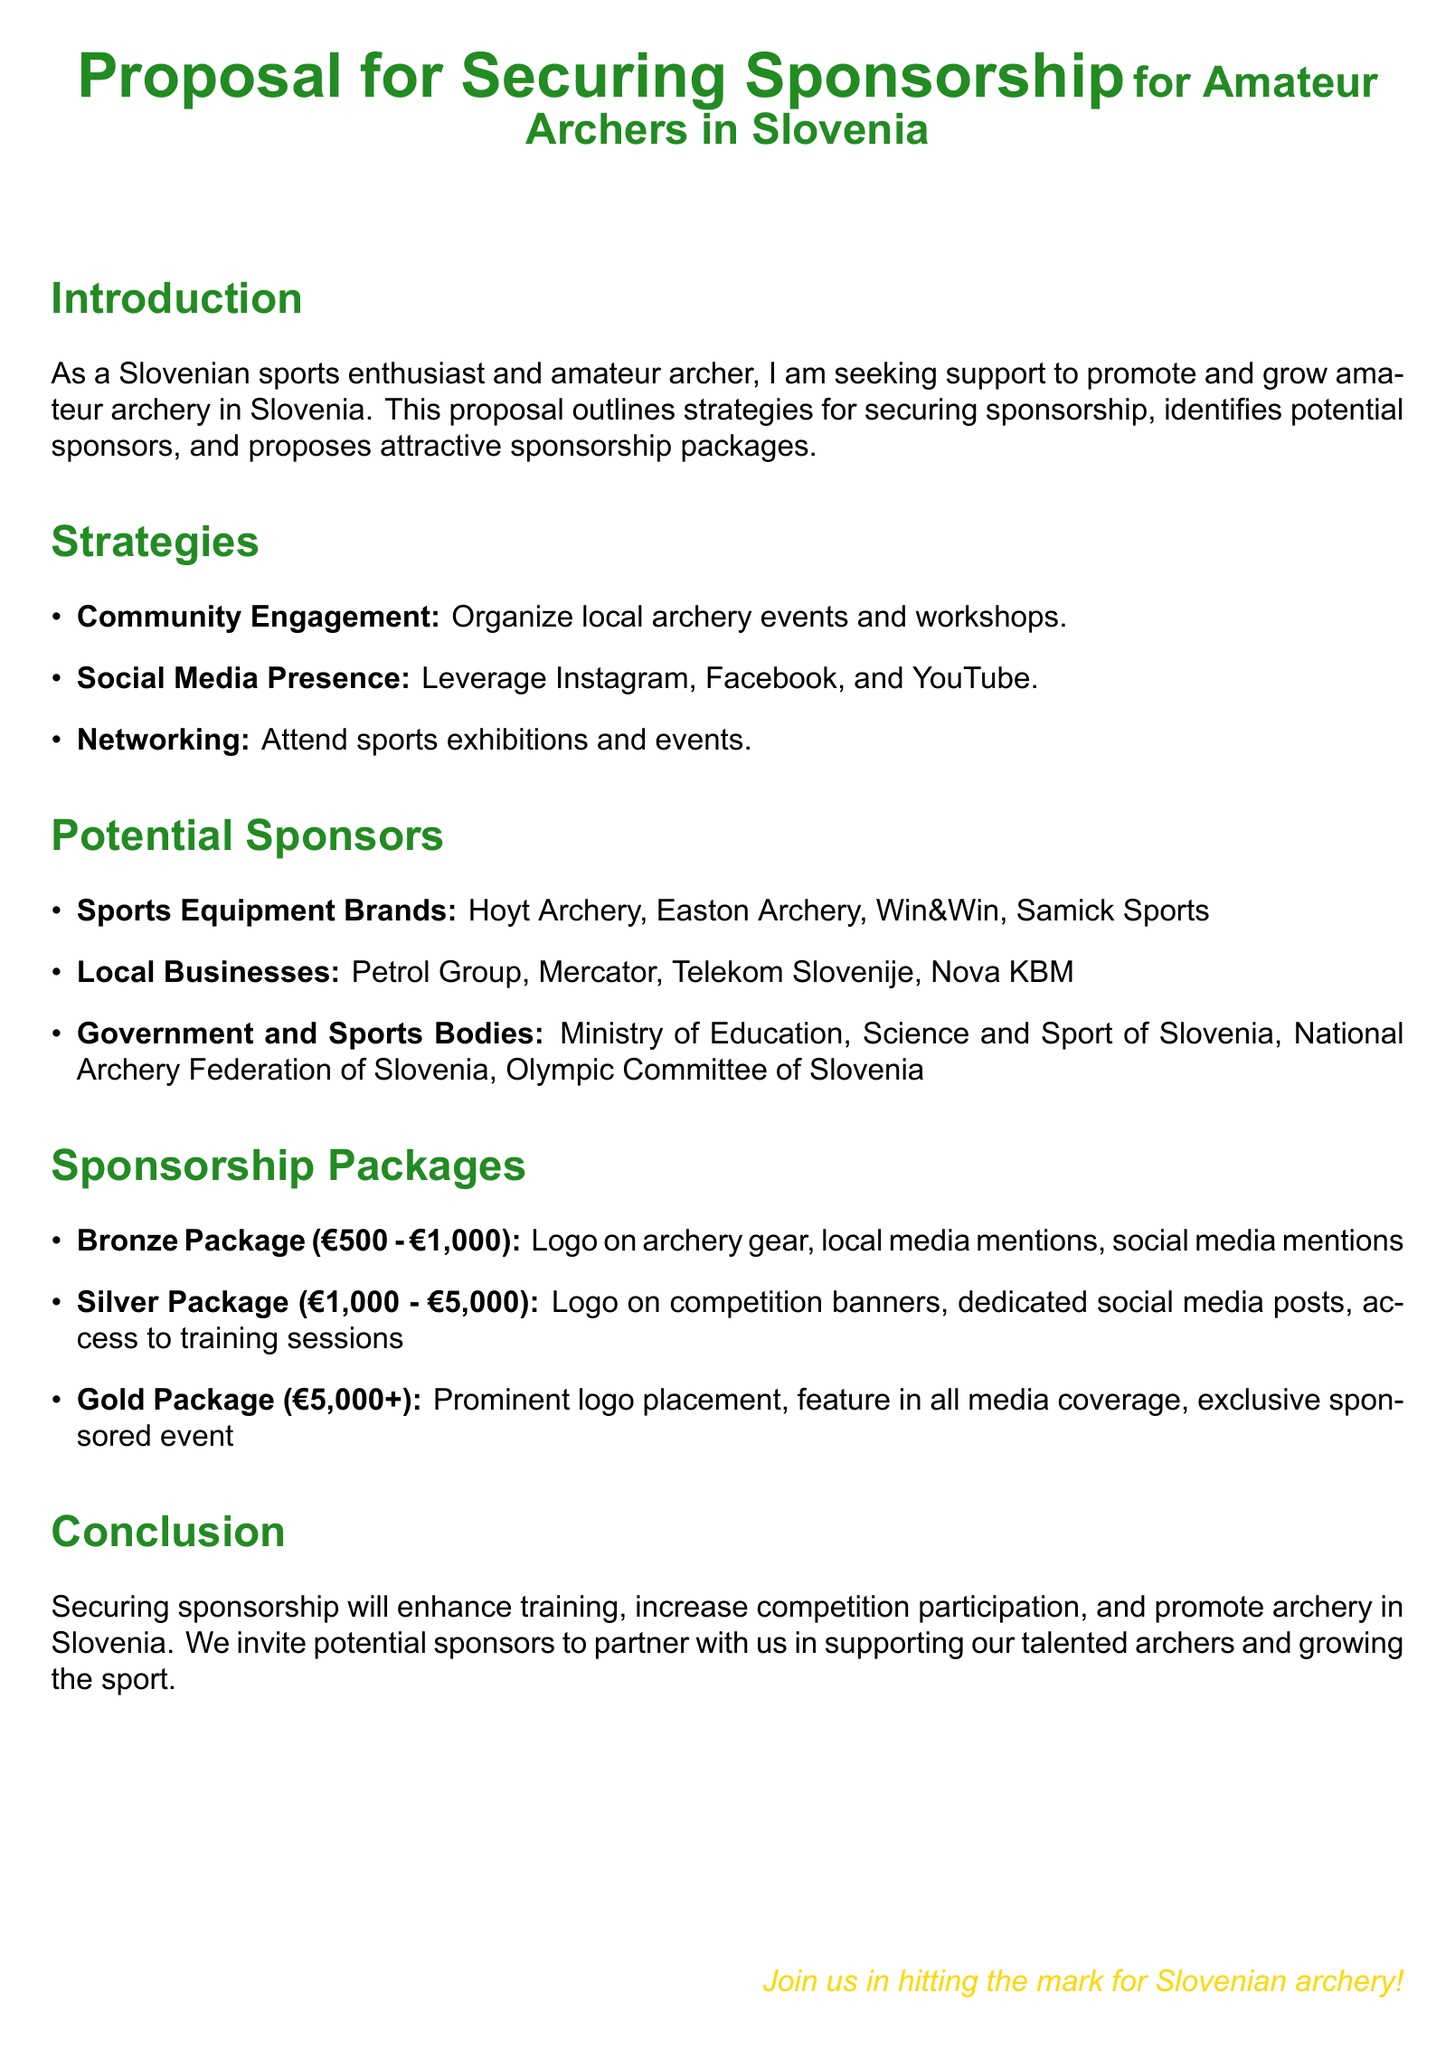What is the primary goal of the proposal? The proposal aims to promote and grow amateur archery in Slovenia through securing sponsorship.
Answer: Promote and grow amateur archery What are the three main strategies mentioned for securing sponsorship? The document lists community engagement, social media presence, and networking as strategies for sponsorship.
Answer: Community engagement, social media presence, networking What is the price range for the Bronze Sponsorship Package? The document specifies that the Bronze Package costs between 500 and 1,000 euros.
Answer: 500 - 1,000 euros Which local business is mentioned as a potential sponsor? The proposal includes Petrol Group as one of the local businesses that could be a sponsor.
Answer: Petrol Group How much does the Gold Sponsorship Package cost? According to the document, the Gold Package starts from 5,000 euros and above.
Answer: 5,000+ euros What specific benefit does the Silver Package offer? The Silver Package includes dedicated social media posts as one of its benefits.
Answer: Dedicated social media posts Which government body is listed as a potential sponsor? The Ministry of Education, Science, and Sport of Slovenia is named as a potential sponsor.
Answer: Ministry of Education, Science, and Sport of Slovenia What is the concluding message of the proposal? The conclusion encourages sponsors to join in supporting Slovenian archery.
Answer: Join us in hitting the mark for Slovenian archery! 